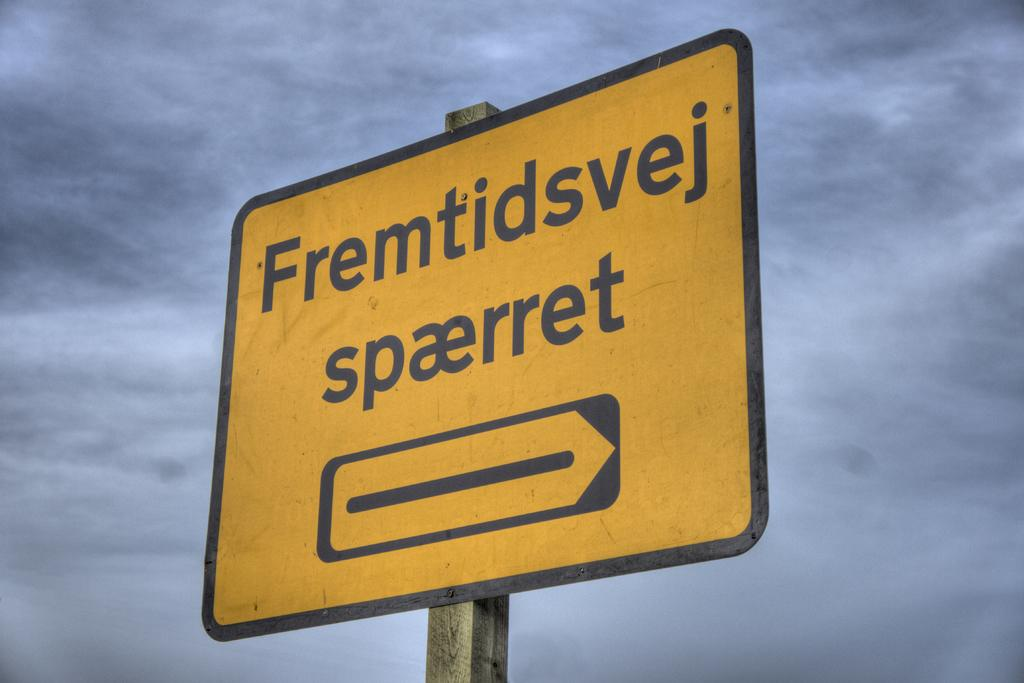Provide a one-sentence caption for the provided image. the word spaerret is on a yellow sign. 